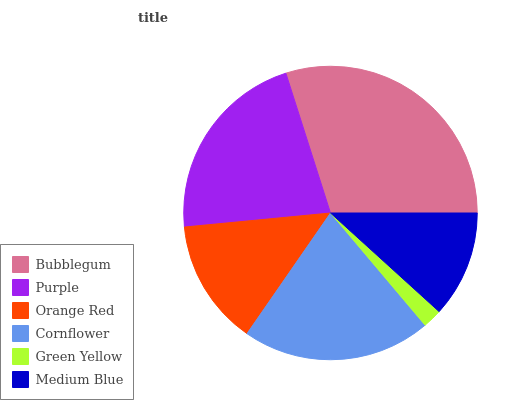Is Green Yellow the minimum?
Answer yes or no. Yes. Is Bubblegum the maximum?
Answer yes or no. Yes. Is Purple the minimum?
Answer yes or no. No. Is Purple the maximum?
Answer yes or no. No. Is Bubblegum greater than Purple?
Answer yes or no. Yes. Is Purple less than Bubblegum?
Answer yes or no. Yes. Is Purple greater than Bubblegum?
Answer yes or no. No. Is Bubblegum less than Purple?
Answer yes or no. No. Is Cornflower the high median?
Answer yes or no. Yes. Is Orange Red the low median?
Answer yes or no. Yes. Is Medium Blue the high median?
Answer yes or no. No. Is Bubblegum the low median?
Answer yes or no. No. 